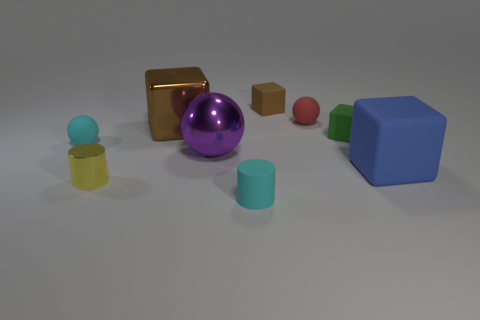Subtract all cyan cubes. Subtract all green balls. How many cubes are left? 4 Add 1 tiny cubes. How many objects exist? 10 Add 2 tiny shiny objects. How many tiny shiny objects exist? 3 Subtract 1 cyan balls. How many objects are left? 8 Subtract all blocks. How many objects are left? 5 Subtract all small cyan objects. Subtract all cyan cylinders. How many objects are left? 6 Add 7 green blocks. How many green blocks are left? 8 